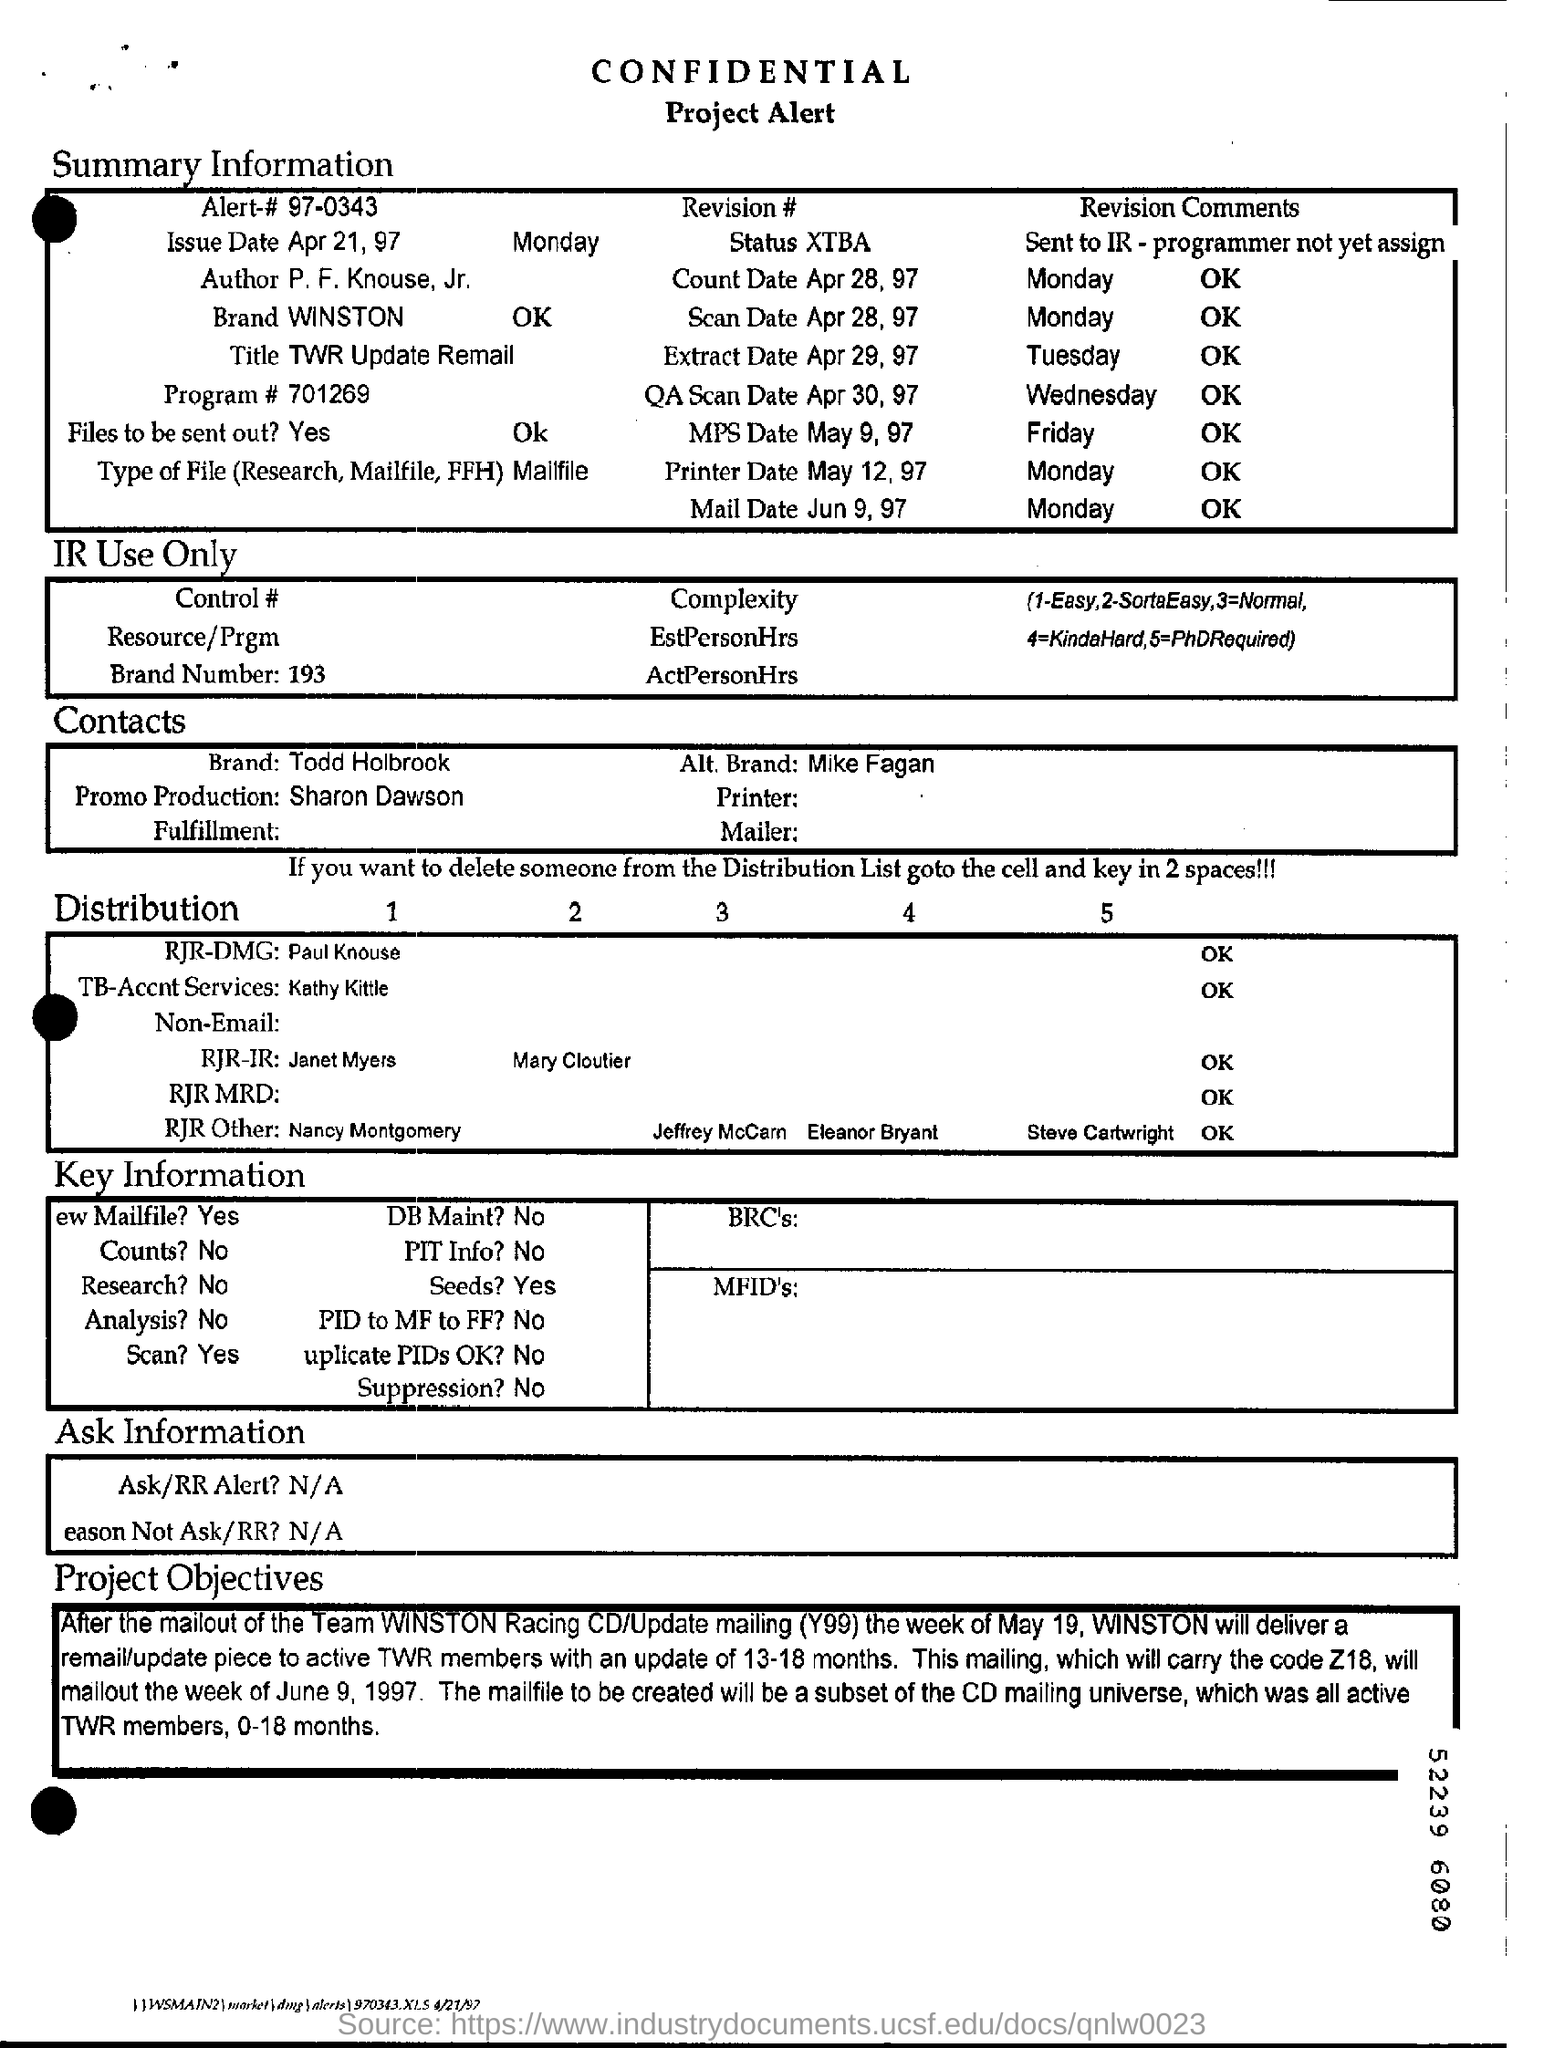Outline some significant characteristics in this image. The title under summary information is a TWR update remail. 